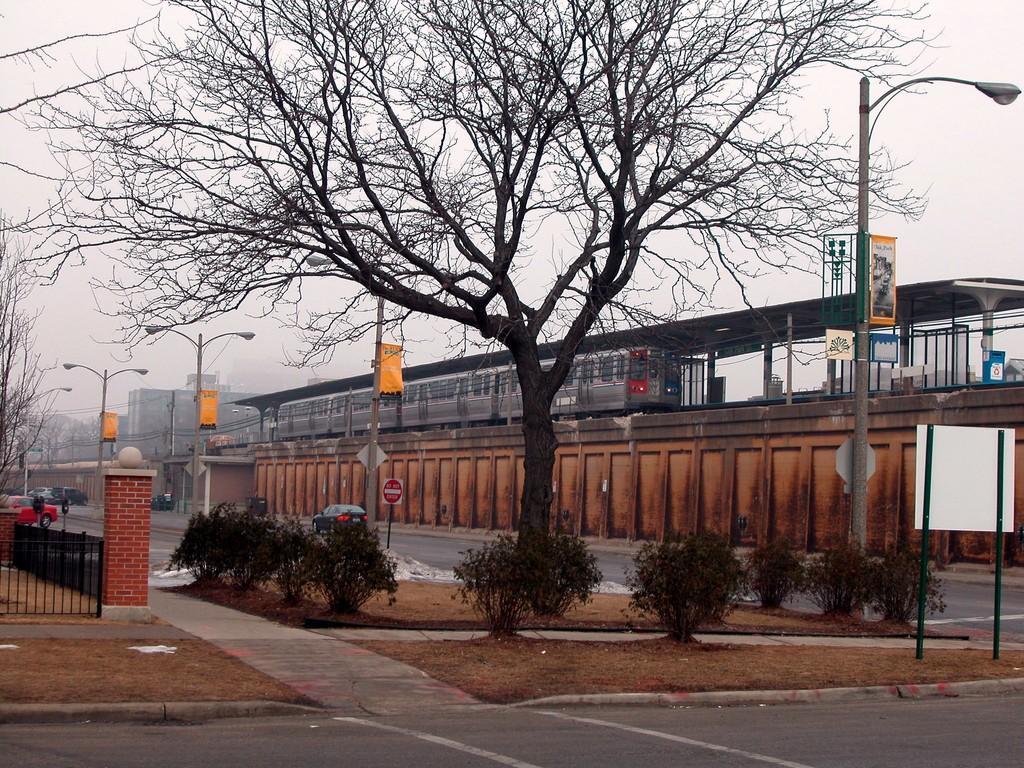Please provide a concise description of this image. Here in this picture in the front we can see roads present and we can also see some part of ground is covered with grass, plants and trees and in the middle of the road we can see light posts with hoardings hanging on it and we can also see a train present on the track and beside that we can see the platform covered with shed and in the far we can see buildings present and we can also see cars and other vehicles also present on the road and we can see the sky is cloudy. 